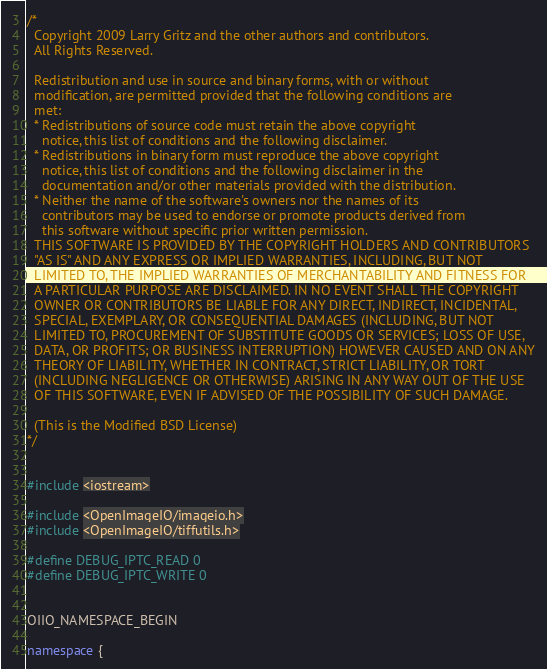<code> <loc_0><loc_0><loc_500><loc_500><_C++_>/*
  Copyright 2009 Larry Gritz and the other authors and contributors.
  All Rights Reserved.

  Redistribution and use in source and binary forms, with or without
  modification, are permitted provided that the following conditions are
  met:
  * Redistributions of source code must retain the above copyright
    notice, this list of conditions and the following disclaimer.
  * Redistributions in binary form must reproduce the above copyright
    notice, this list of conditions and the following disclaimer in the
    documentation and/or other materials provided with the distribution.
  * Neither the name of the software's owners nor the names of its
    contributors may be used to endorse or promote products derived from
    this software without specific prior written permission.
  THIS SOFTWARE IS PROVIDED BY THE COPYRIGHT HOLDERS AND CONTRIBUTORS
  "AS IS" AND ANY EXPRESS OR IMPLIED WARRANTIES, INCLUDING, BUT NOT
  LIMITED TO, THE IMPLIED WARRANTIES OF MERCHANTABILITY AND FITNESS FOR
  A PARTICULAR PURPOSE ARE DISCLAIMED. IN NO EVENT SHALL THE COPYRIGHT
  OWNER OR CONTRIBUTORS BE LIABLE FOR ANY DIRECT, INDIRECT, INCIDENTAL,
  SPECIAL, EXEMPLARY, OR CONSEQUENTIAL DAMAGES (INCLUDING, BUT NOT
  LIMITED TO, PROCUREMENT OF SUBSTITUTE GOODS OR SERVICES; LOSS OF USE,
  DATA, OR PROFITS; OR BUSINESS INTERRUPTION) HOWEVER CAUSED AND ON ANY
  THEORY OF LIABILITY, WHETHER IN CONTRACT, STRICT LIABILITY, OR TORT
  (INCLUDING NEGLIGENCE OR OTHERWISE) ARISING IN ANY WAY OUT OF THE USE
  OF THIS SOFTWARE, EVEN IF ADVISED OF THE POSSIBILITY OF SUCH DAMAGE.

  (This is the Modified BSD License)
*/


#include <iostream>

#include <OpenImageIO/imageio.h>
#include <OpenImageIO/tiffutils.h>

#define DEBUG_IPTC_READ 0
#define DEBUG_IPTC_WRITE 0


OIIO_NAMESPACE_BEGIN

namespace {
</code> 